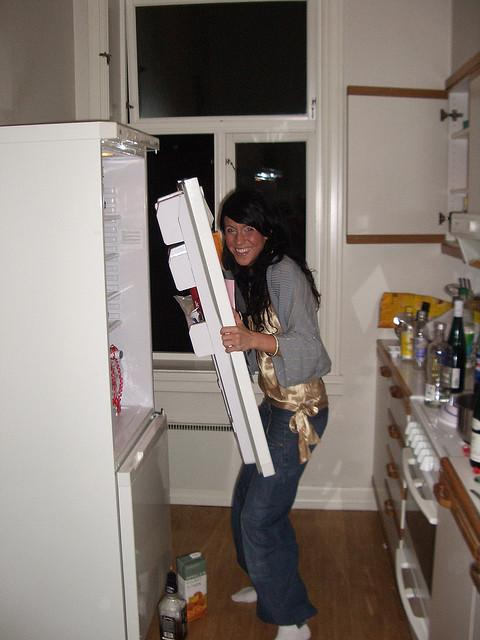What will happen to the refrigerator next? Please explain your reasoning. warm up. The refrigerator will warm up without a door on it. 